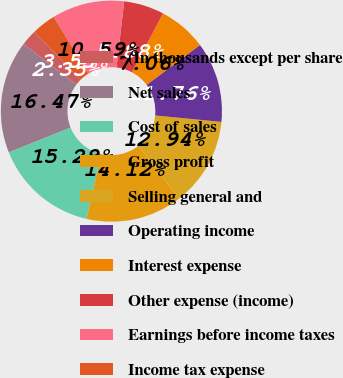<chart> <loc_0><loc_0><loc_500><loc_500><pie_chart><fcel>(In thousands except per share<fcel>Net sales<fcel>Cost of sales<fcel>Gross profit<fcel>Selling general and<fcel>Operating income<fcel>Interest expense<fcel>Other expense (income)<fcel>Earnings before income taxes<fcel>Income tax expense<nl><fcel>2.35%<fcel>16.47%<fcel>15.29%<fcel>14.12%<fcel>12.94%<fcel>11.76%<fcel>7.06%<fcel>5.88%<fcel>10.59%<fcel>3.53%<nl></chart> 